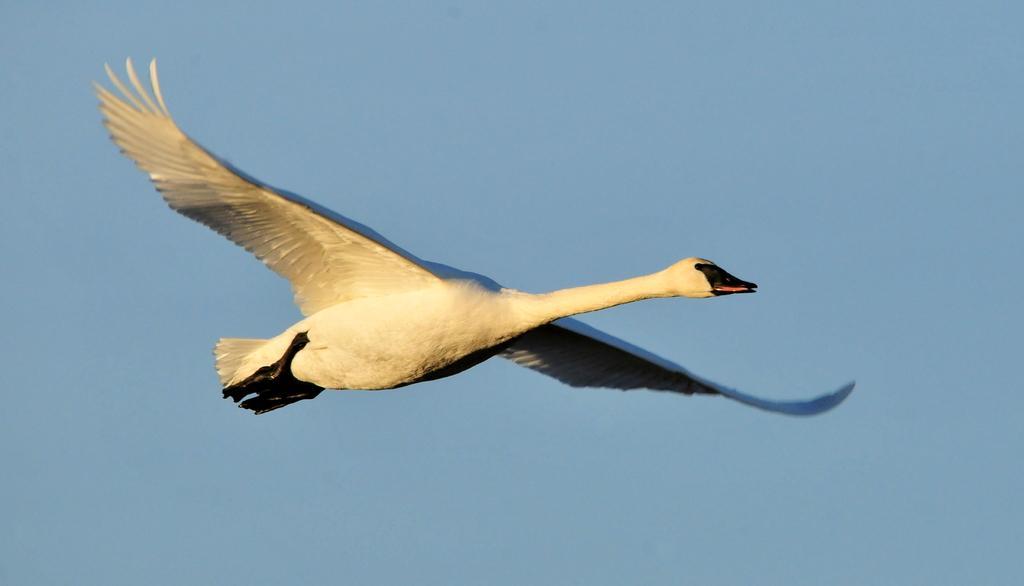Describe this image in one or two sentences. In this picture I can see a bird flying, it is white and black in color and I can see blue sky. 